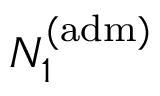Convert formula to latex. <formula><loc_0><loc_0><loc_500><loc_500>N _ { 1 } ^ { ( a d m ) }</formula> 